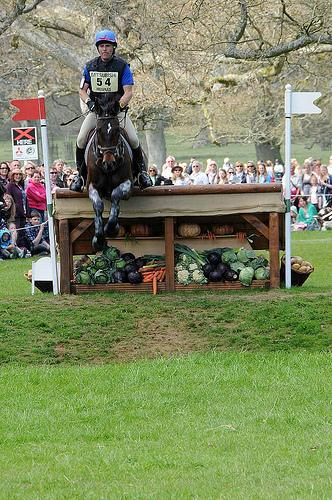What color is the man's shirt, and what other accessories is he wearing? The man has a blue shirt and is wearing a black vest, black gloves, tan pants, and black boots. What objects are on top of the stand that the horse is jumping over? There is a white flag, red flag, and various vegetables like carrots, cabbages, and cauliflower on the stand that the horse is jumping over. What kind of objects are there in the baskets and containers? There are potatoes in a basket, carrots in a container, cabbage in a container, and cauliflower heads in another container. List the colors and types of flags in the image. There are two flags in the image: a red flag and a white flag. Describe the vegetables that can be found at the bottom of the hurdle. Carrots, cabbages, cauliflowers, and pumpkins can be found at the bottom of the hurdle. What is the color and type of the two poles in the image? There is a brown pole and a white flag pole. Mention the horse's attire and the colors. The horse is wearing black shoes and is jumping over a brown fence. What is happening at the horse competition? A man is riding a horse and jumping over a hurdle with a vegetable stand beneath it. What type of helmet is the man wearing and what is the color? The man is wearing a blue helmet. Identify the people watching the horse event. There is a crowd of people watching the horse competition. 